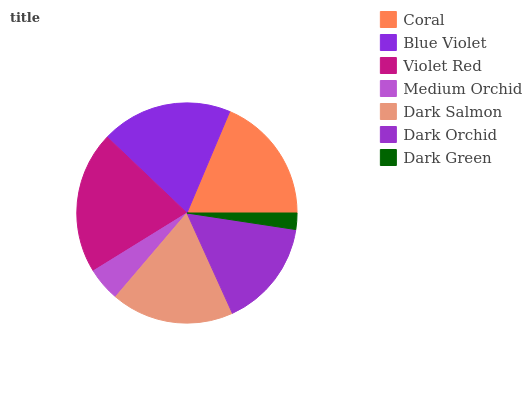Is Dark Green the minimum?
Answer yes or no. Yes. Is Violet Red the maximum?
Answer yes or no. Yes. Is Blue Violet the minimum?
Answer yes or no. No. Is Blue Violet the maximum?
Answer yes or no. No. Is Blue Violet greater than Coral?
Answer yes or no. Yes. Is Coral less than Blue Violet?
Answer yes or no. Yes. Is Coral greater than Blue Violet?
Answer yes or no. No. Is Blue Violet less than Coral?
Answer yes or no. No. Is Dark Salmon the high median?
Answer yes or no. Yes. Is Dark Salmon the low median?
Answer yes or no. Yes. Is Blue Violet the high median?
Answer yes or no. No. Is Violet Red the low median?
Answer yes or no. No. 